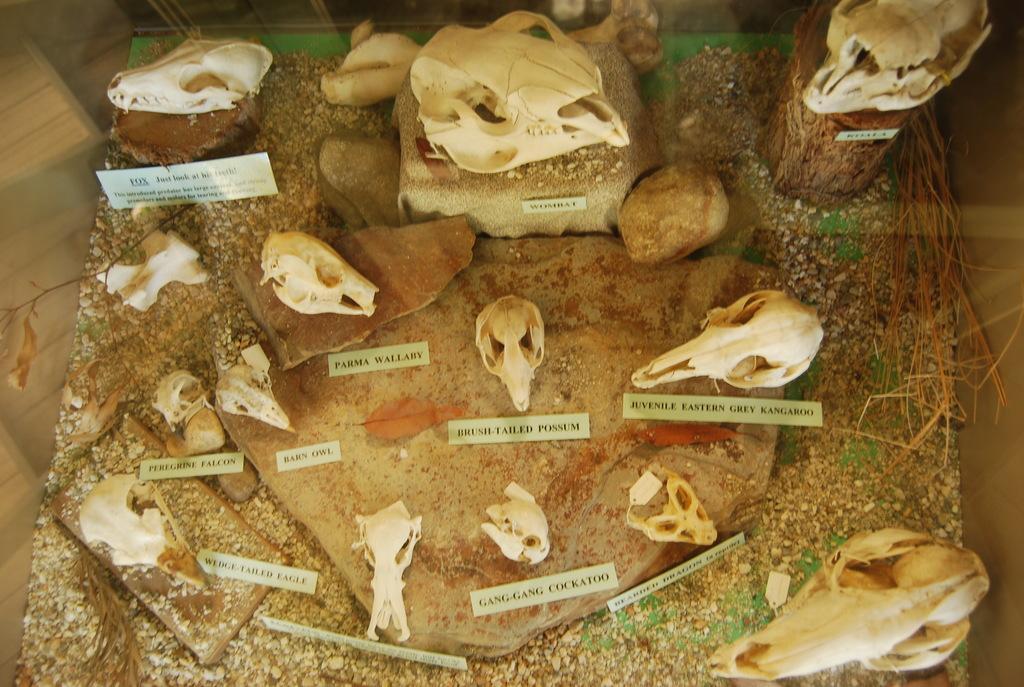What type of objects are on the table in the image? There are skulls of animals on the table. What other objects are near the table? There are stones on or near the table. Are there any signs or labels present in the image? Yes, there are name boards with text on them beside the skulls and stones. What type of cord is used to hold the skulls in place in the image? There is no cord visible in the image; the skulls are simply placed on the table. 